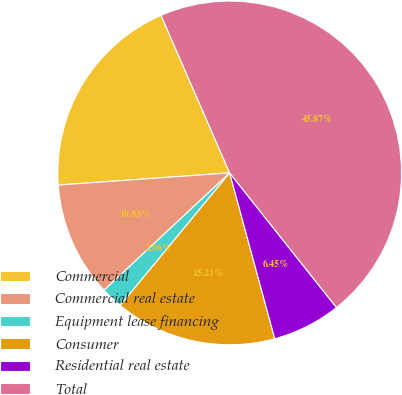Convert chart. <chart><loc_0><loc_0><loc_500><loc_500><pie_chart><fcel>Commercial<fcel>Commercial real estate<fcel>Equipment lease financing<fcel>Consumer<fcel>Residential real estate<fcel>Total<nl><fcel>19.59%<fcel>10.83%<fcel>2.06%<fcel>15.21%<fcel>6.45%<fcel>45.87%<nl></chart> 